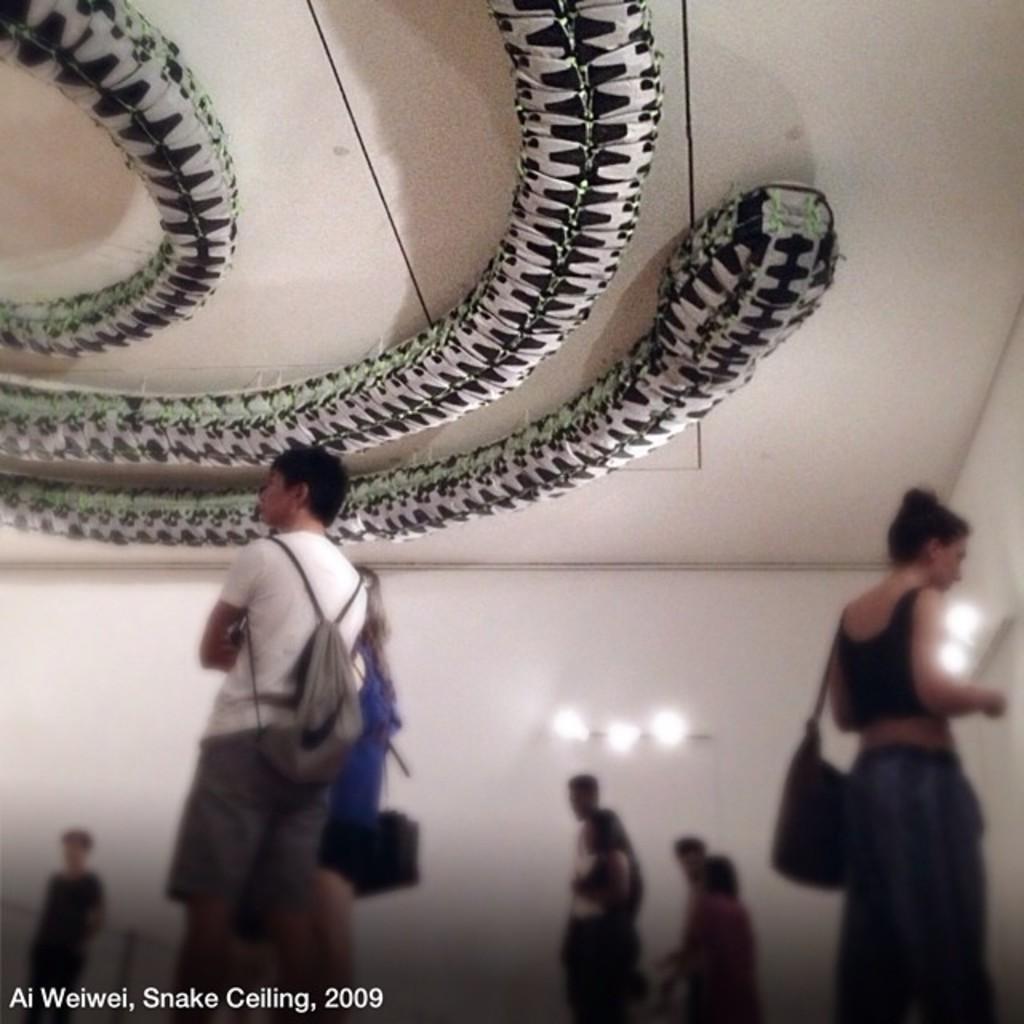Please provide a concise description of this image. In this image people are standing on the floor. At the back side there are lights attached to the wall. 